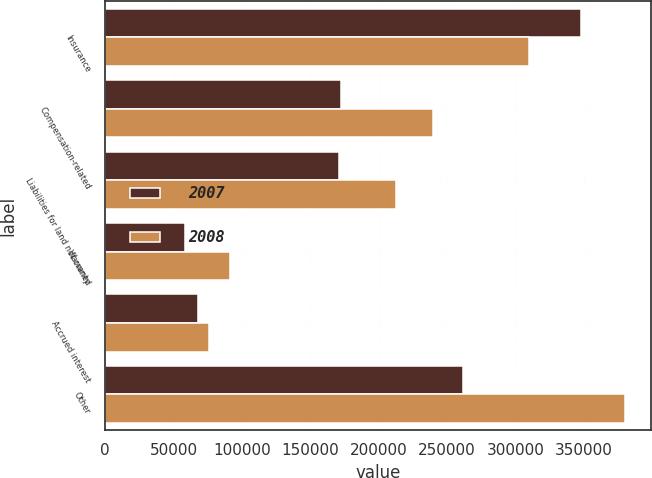Convert chart to OTSL. <chart><loc_0><loc_0><loc_500><loc_500><stacked_bar_chart><ecel><fcel>Insurance<fcel>Compensation-related<fcel>Liabilities for land not owned<fcel>Warranty<fcel>Accrued interest<fcel>Other<nl><fcel>2007<fcel>347631<fcel>172524<fcel>171101<fcel>58178<fcel>67878<fcel>261883<nl><fcel>2008<fcel>309874<fcel>239756<fcel>212235<fcel>90917<fcel>75782<fcel>379990<nl></chart> 